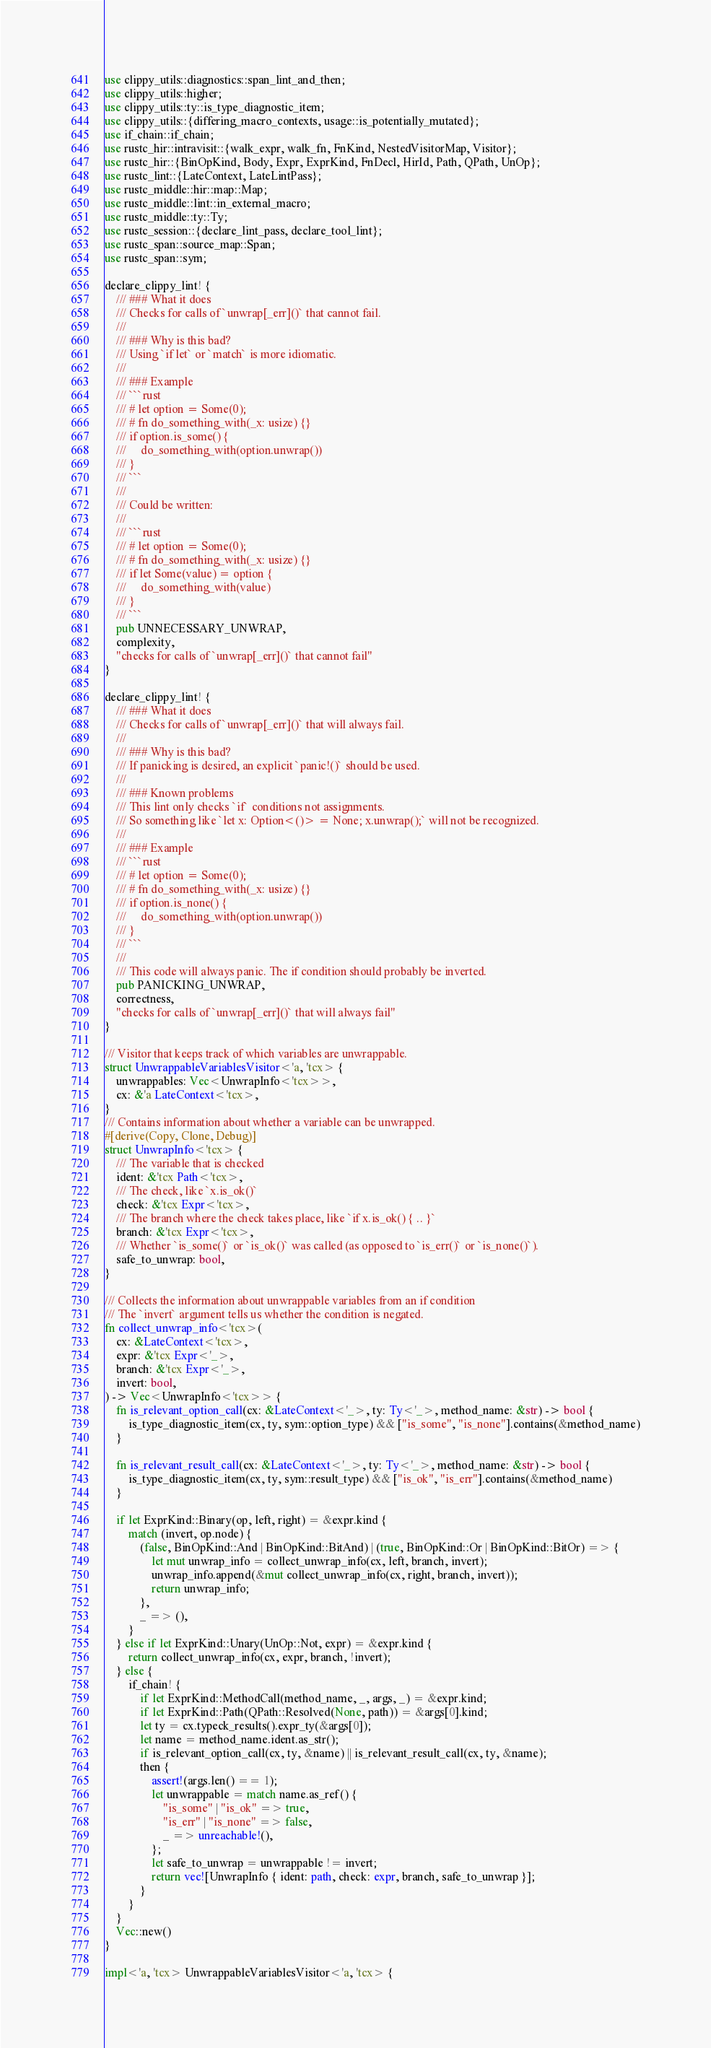Convert code to text. <code><loc_0><loc_0><loc_500><loc_500><_Rust_>use clippy_utils::diagnostics::span_lint_and_then;
use clippy_utils::higher;
use clippy_utils::ty::is_type_diagnostic_item;
use clippy_utils::{differing_macro_contexts, usage::is_potentially_mutated};
use if_chain::if_chain;
use rustc_hir::intravisit::{walk_expr, walk_fn, FnKind, NestedVisitorMap, Visitor};
use rustc_hir::{BinOpKind, Body, Expr, ExprKind, FnDecl, HirId, Path, QPath, UnOp};
use rustc_lint::{LateContext, LateLintPass};
use rustc_middle::hir::map::Map;
use rustc_middle::lint::in_external_macro;
use rustc_middle::ty::Ty;
use rustc_session::{declare_lint_pass, declare_tool_lint};
use rustc_span::source_map::Span;
use rustc_span::sym;

declare_clippy_lint! {
    /// ### What it does
    /// Checks for calls of `unwrap[_err]()` that cannot fail.
    ///
    /// ### Why is this bad?
    /// Using `if let` or `match` is more idiomatic.
    ///
    /// ### Example
    /// ```rust
    /// # let option = Some(0);
    /// # fn do_something_with(_x: usize) {}
    /// if option.is_some() {
    ///     do_something_with(option.unwrap())
    /// }
    /// ```
    ///
    /// Could be written:
    ///
    /// ```rust
    /// # let option = Some(0);
    /// # fn do_something_with(_x: usize) {}
    /// if let Some(value) = option {
    ///     do_something_with(value)
    /// }
    /// ```
    pub UNNECESSARY_UNWRAP,
    complexity,
    "checks for calls of `unwrap[_err]()` that cannot fail"
}

declare_clippy_lint! {
    /// ### What it does
    /// Checks for calls of `unwrap[_err]()` that will always fail.
    ///
    /// ### Why is this bad?
    /// If panicking is desired, an explicit `panic!()` should be used.
    ///
    /// ### Known problems
    /// This lint only checks `if` conditions not assignments.
    /// So something like `let x: Option<()> = None; x.unwrap();` will not be recognized.
    ///
    /// ### Example
    /// ```rust
    /// # let option = Some(0);
    /// # fn do_something_with(_x: usize) {}
    /// if option.is_none() {
    ///     do_something_with(option.unwrap())
    /// }
    /// ```
    ///
    /// This code will always panic. The if condition should probably be inverted.
    pub PANICKING_UNWRAP,
    correctness,
    "checks for calls of `unwrap[_err]()` that will always fail"
}

/// Visitor that keeps track of which variables are unwrappable.
struct UnwrappableVariablesVisitor<'a, 'tcx> {
    unwrappables: Vec<UnwrapInfo<'tcx>>,
    cx: &'a LateContext<'tcx>,
}
/// Contains information about whether a variable can be unwrapped.
#[derive(Copy, Clone, Debug)]
struct UnwrapInfo<'tcx> {
    /// The variable that is checked
    ident: &'tcx Path<'tcx>,
    /// The check, like `x.is_ok()`
    check: &'tcx Expr<'tcx>,
    /// The branch where the check takes place, like `if x.is_ok() { .. }`
    branch: &'tcx Expr<'tcx>,
    /// Whether `is_some()` or `is_ok()` was called (as opposed to `is_err()` or `is_none()`).
    safe_to_unwrap: bool,
}

/// Collects the information about unwrappable variables from an if condition
/// The `invert` argument tells us whether the condition is negated.
fn collect_unwrap_info<'tcx>(
    cx: &LateContext<'tcx>,
    expr: &'tcx Expr<'_>,
    branch: &'tcx Expr<'_>,
    invert: bool,
) -> Vec<UnwrapInfo<'tcx>> {
    fn is_relevant_option_call(cx: &LateContext<'_>, ty: Ty<'_>, method_name: &str) -> bool {
        is_type_diagnostic_item(cx, ty, sym::option_type) && ["is_some", "is_none"].contains(&method_name)
    }

    fn is_relevant_result_call(cx: &LateContext<'_>, ty: Ty<'_>, method_name: &str) -> bool {
        is_type_diagnostic_item(cx, ty, sym::result_type) && ["is_ok", "is_err"].contains(&method_name)
    }

    if let ExprKind::Binary(op, left, right) = &expr.kind {
        match (invert, op.node) {
            (false, BinOpKind::And | BinOpKind::BitAnd) | (true, BinOpKind::Or | BinOpKind::BitOr) => {
                let mut unwrap_info = collect_unwrap_info(cx, left, branch, invert);
                unwrap_info.append(&mut collect_unwrap_info(cx, right, branch, invert));
                return unwrap_info;
            },
            _ => (),
        }
    } else if let ExprKind::Unary(UnOp::Not, expr) = &expr.kind {
        return collect_unwrap_info(cx, expr, branch, !invert);
    } else {
        if_chain! {
            if let ExprKind::MethodCall(method_name, _, args, _) = &expr.kind;
            if let ExprKind::Path(QPath::Resolved(None, path)) = &args[0].kind;
            let ty = cx.typeck_results().expr_ty(&args[0]);
            let name = method_name.ident.as_str();
            if is_relevant_option_call(cx, ty, &name) || is_relevant_result_call(cx, ty, &name);
            then {
                assert!(args.len() == 1);
                let unwrappable = match name.as_ref() {
                    "is_some" | "is_ok" => true,
                    "is_err" | "is_none" => false,
                    _ => unreachable!(),
                };
                let safe_to_unwrap = unwrappable != invert;
                return vec![UnwrapInfo { ident: path, check: expr, branch, safe_to_unwrap }];
            }
        }
    }
    Vec::new()
}

impl<'a, 'tcx> UnwrappableVariablesVisitor<'a, 'tcx> {</code> 